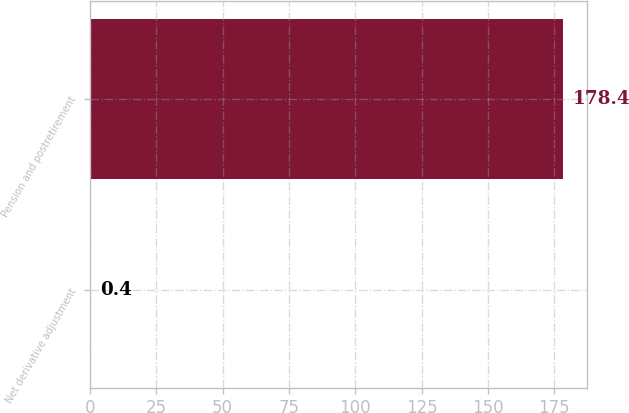Convert chart to OTSL. <chart><loc_0><loc_0><loc_500><loc_500><bar_chart><fcel>Net derivative adjustment<fcel>Pension and postretirement<nl><fcel>0.4<fcel>178.4<nl></chart> 